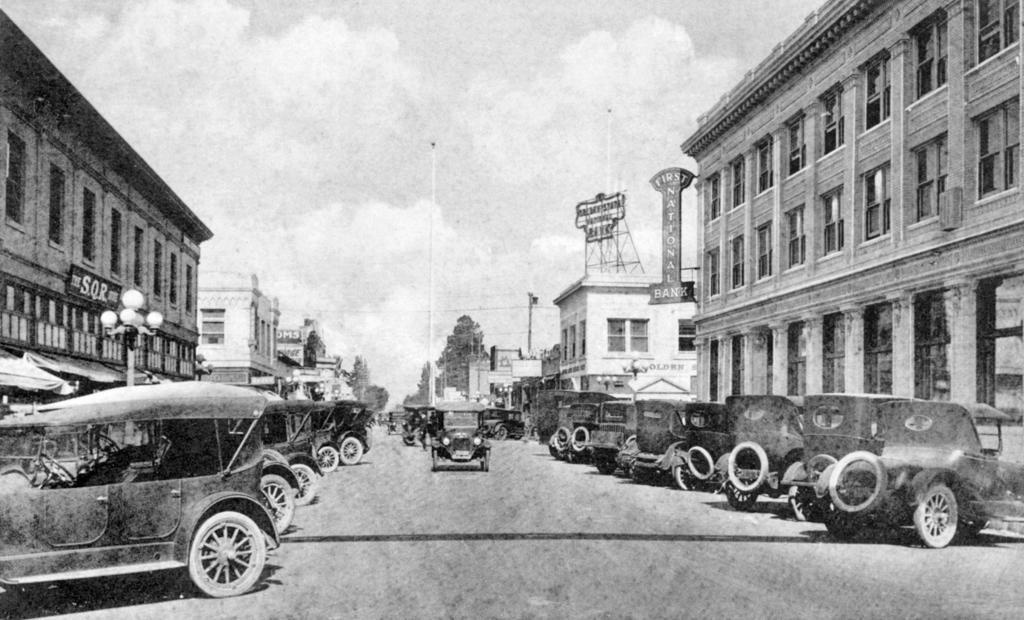Describe this image in one or two sentences. This is a black and white image. In the foreground we can see the group of vehicles and we can see the buildings and some boards on which the text is printed. In the background there is a sky, trees and poles and some other objects. 